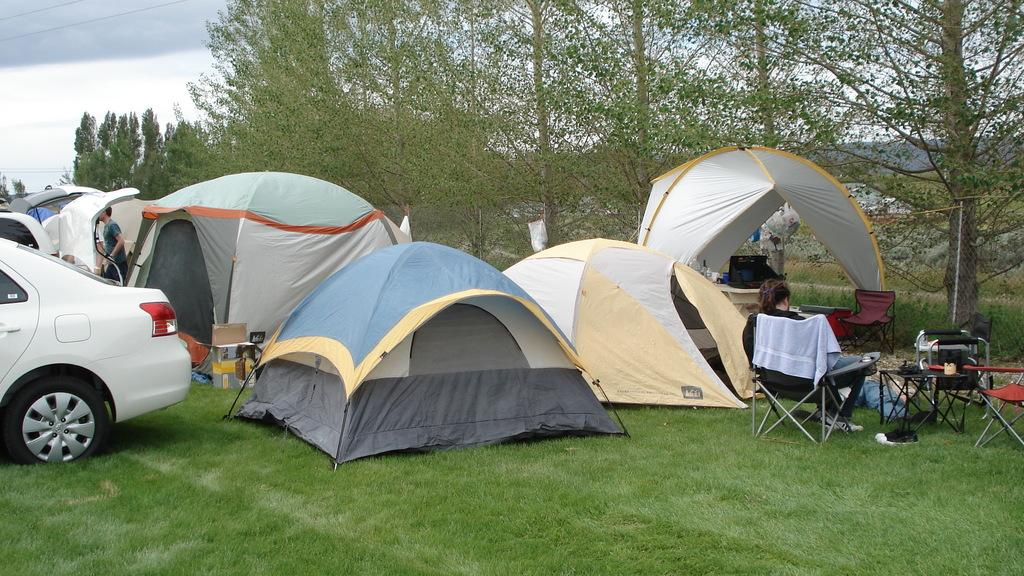What type of temporary shelters can be seen in the image? There are tents in the image. What mode of transportation is present in the image? There is a vehicle in the image. How many persons are visible in the image? There are persons in the image. What type of seating is available in the image? There are chairs in the image. What type of surface is present for placing items in the image? There is a table in the image. What type of natural vegetation is visible in the image? There are trees in the image. What is visible at the top of the image? The sky is visible in the image, and there are clouds visible in the image. What type of creature is shown interacting with the tents in the image? There is no creature shown interacting with the tents in the image; only the tents, vehicle, persons, chairs, table, trees, sky, and clouds are present. What type of base is visible in the image? There is no base present in the image; it features tents, a vehicle, persons, chairs, a table, trees, sky, and clouds. 